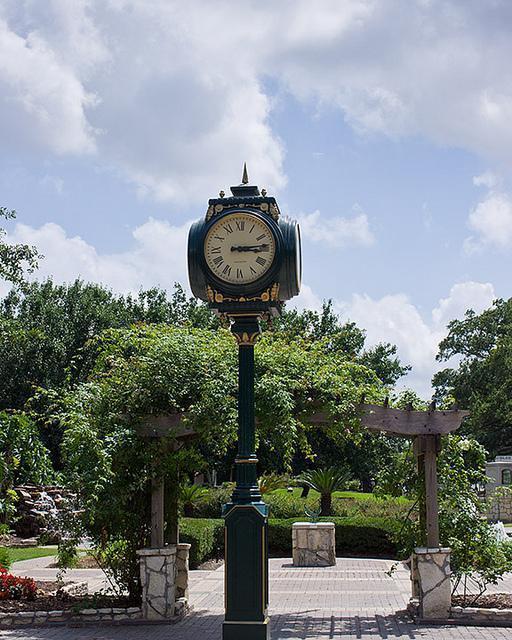How many clocks are there?
Give a very brief answer. 1. How many potted plants are there?
Give a very brief answer. 2. 